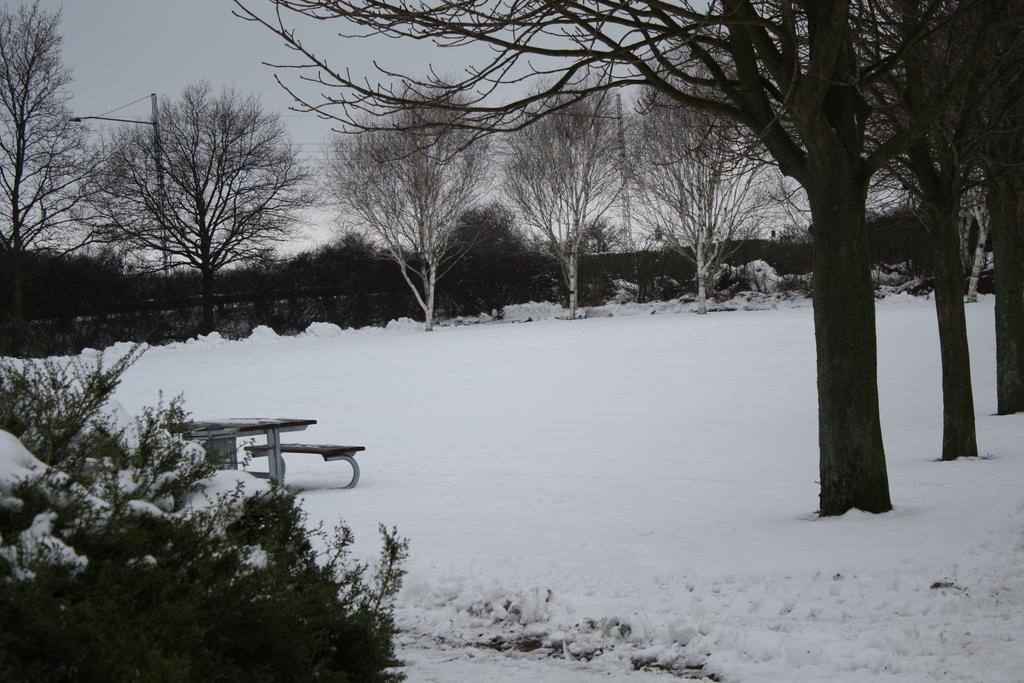What type of vegetation can be seen in the image? There are trees in the image. Where is the bench located in the image? The bench is on the left side of the image. What is the weather like in the image? There is snow visible in the image, indicating a cold or wintery weather. What is visible in the background of the image? There is sky visible in the background of the image. What structures can be seen in the image? There are poles in the image. What grade is the student sitting on the bench in the image? There is no student or bench in the image; it features trees, snow, sky, and poles. What scene is depicted in the image? The image does not depict a scene; it is a photograph of trees, snow, sky, and poles. 